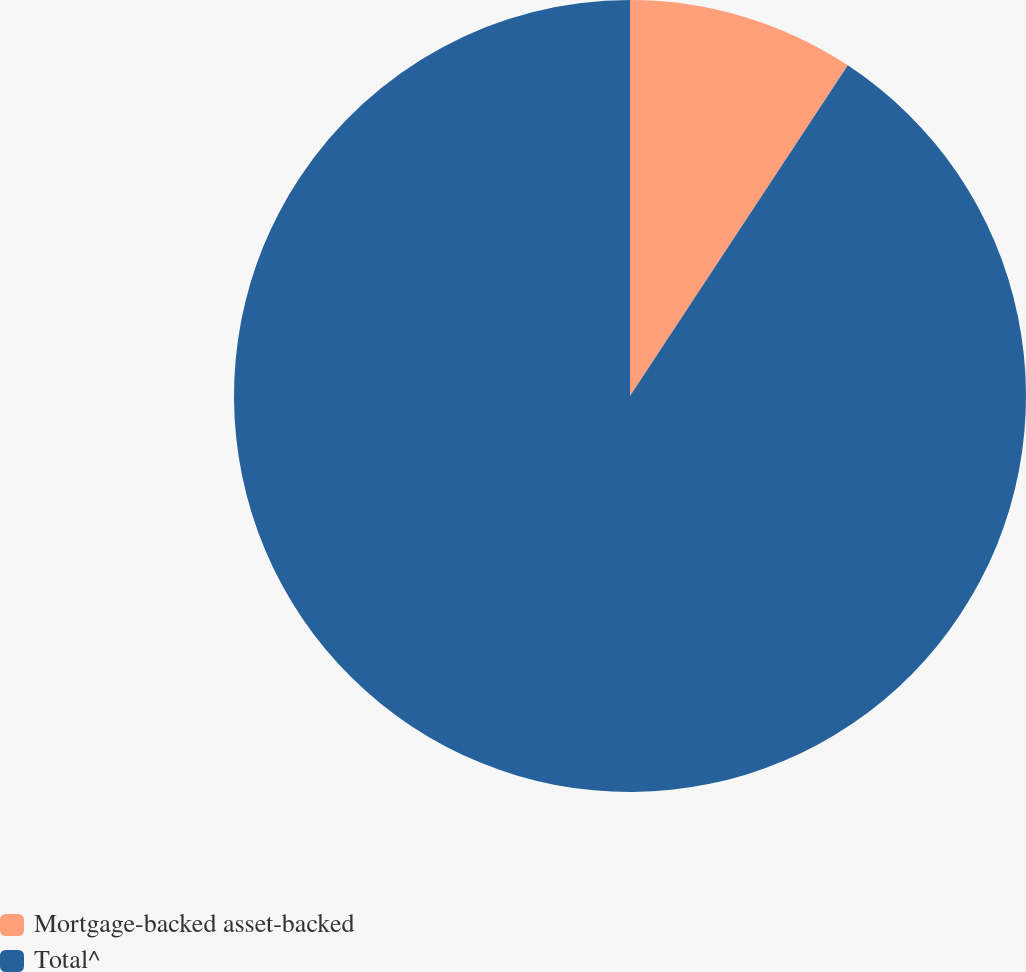Convert chart. <chart><loc_0><loc_0><loc_500><loc_500><pie_chart><fcel>Mortgage-backed asset-backed<fcel>Total^<nl><fcel>9.27%<fcel>90.73%<nl></chart> 